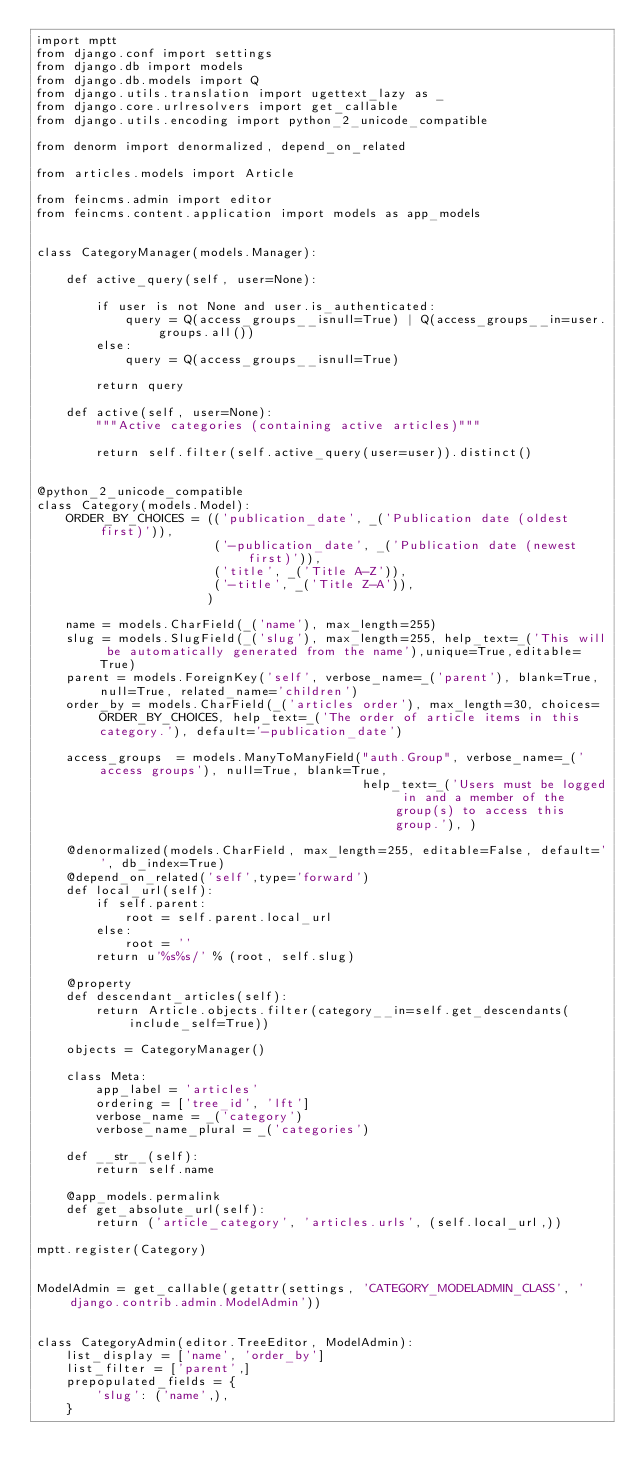Convert code to text. <code><loc_0><loc_0><loc_500><loc_500><_Python_>import mptt
from django.conf import settings
from django.db import models
from django.db.models import Q
from django.utils.translation import ugettext_lazy as _
from django.core.urlresolvers import get_callable
from django.utils.encoding import python_2_unicode_compatible

from denorm import denormalized, depend_on_related

from articles.models import Article

from feincms.admin import editor
from feincms.content.application import models as app_models


class CategoryManager(models.Manager):

    def active_query(self, user=None):

        if user is not None and user.is_authenticated:
            query = Q(access_groups__isnull=True) | Q(access_groups__in=user.groups.all())
        else:
            query = Q(access_groups__isnull=True)

        return query

    def active(self, user=None):
        """Active categories (containing active articles)"""

        return self.filter(self.active_query(user=user)).distinct()


@python_2_unicode_compatible
class Category(models.Model):
    ORDER_BY_CHOICES = (('publication_date', _('Publication date (oldest first)')),
                        ('-publication_date', _('Publication date (newest first)')),
                        ('title', _('Title A-Z')),
                        ('-title', _('Title Z-A')),
                       )

    name = models.CharField(_('name'), max_length=255)
    slug = models.SlugField(_('slug'), max_length=255, help_text=_('This will be automatically generated from the name'),unique=True,editable=True)
    parent = models.ForeignKey('self', verbose_name=_('parent'), blank=True, null=True, related_name='children')
    order_by = models.CharField(_('articles order'), max_length=30, choices=ORDER_BY_CHOICES, help_text=_('The order of article items in this category.'), default='-publication_date')

    access_groups  = models.ManyToManyField("auth.Group", verbose_name=_('access groups'), null=True, blank=True,
                                            help_text=_('Users must be logged in and a member of the group(s) to access this group.'), )

    @denormalized(models.CharField, max_length=255, editable=False, default='', db_index=True)
    @depend_on_related('self',type='forward')
    def local_url(self):
        if self.parent:
            root = self.parent.local_url
        else:
            root = ''
        return u'%s%s/' % (root, self.slug)

    @property
    def descendant_articles(self):
        return Article.objects.filter(category__in=self.get_descendants(include_self=True))

    objects = CategoryManager()

    class Meta:
        app_label = 'articles'
        ordering = ['tree_id', 'lft']
        verbose_name = _('category')
        verbose_name_plural = _('categories')

    def __str__(self):
        return self.name

    @app_models.permalink
    def get_absolute_url(self):
        return ('article_category', 'articles.urls', (self.local_url,))

mptt.register(Category)


ModelAdmin = get_callable(getattr(settings, 'CATEGORY_MODELADMIN_CLASS', 'django.contrib.admin.ModelAdmin'))


class CategoryAdmin(editor.TreeEditor, ModelAdmin):
    list_display = ['name', 'order_by']
    list_filter = ['parent',]
    prepopulated_fields = {
        'slug': ('name',),
    }
</code> 